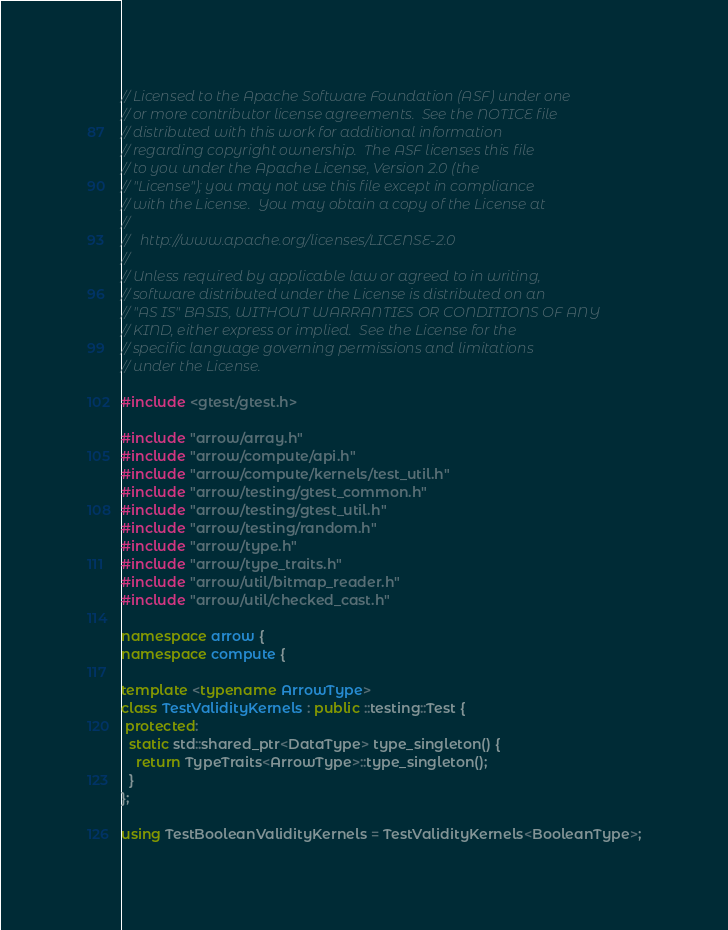<code> <loc_0><loc_0><loc_500><loc_500><_C++_>// Licensed to the Apache Software Foundation (ASF) under one
// or more contributor license agreements.  See the NOTICE file
// distributed with this work for additional information
// regarding copyright ownership.  The ASF licenses this file
// to you under the Apache License, Version 2.0 (the
// "License"); you may not use this file except in compliance
// with the License.  You may obtain a copy of the License at
//
//   http://www.apache.org/licenses/LICENSE-2.0
//
// Unless required by applicable law or agreed to in writing,
// software distributed under the License is distributed on an
// "AS IS" BASIS, WITHOUT WARRANTIES OR CONDITIONS OF ANY
// KIND, either express or implied.  See the License for the
// specific language governing permissions and limitations
// under the License.

#include <gtest/gtest.h>

#include "arrow/array.h"
#include "arrow/compute/api.h"
#include "arrow/compute/kernels/test_util.h"
#include "arrow/testing/gtest_common.h"
#include "arrow/testing/gtest_util.h"
#include "arrow/testing/random.h"
#include "arrow/type.h"
#include "arrow/type_traits.h"
#include "arrow/util/bitmap_reader.h"
#include "arrow/util/checked_cast.h"

namespace arrow {
namespace compute {

template <typename ArrowType>
class TestValidityKernels : public ::testing::Test {
 protected:
  static std::shared_ptr<DataType> type_singleton() {
    return TypeTraits<ArrowType>::type_singleton();
  }
};

using TestBooleanValidityKernels = TestValidityKernels<BooleanType>;</code> 